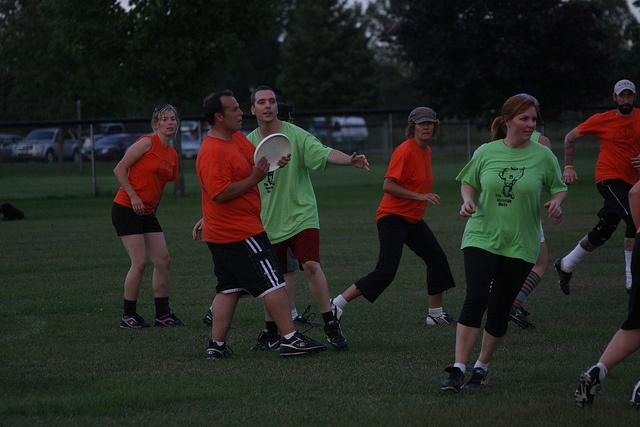Describe the objects in this image and their specific colors. I can see people in black, darkgreen, teal, and green tones, people in black, maroon, and gray tones, people in black, darkgreen, and maroon tones, people in black, maroon, and gray tones, and people in black, maroon, and brown tones in this image. 